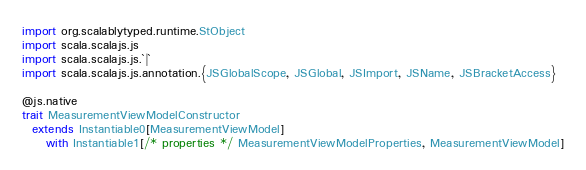<code> <loc_0><loc_0><loc_500><loc_500><_Scala_>import org.scalablytyped.runtime.StObject
import scala.scalajs.js
import scala.scalajs.js.`|`
import scala.scalajs.js.annotation.{JSGlobalScope, JSGlobal, JSImport, JSName, JSBracketAccess}

@js.native
trait MeasurementViewModelConstructor
  extends Instantiable0[MeasurementViewModel]
     with Instantiable1[/* properties */ MeasurementViewModelProperties, MeasurementViewModel]
</code> 